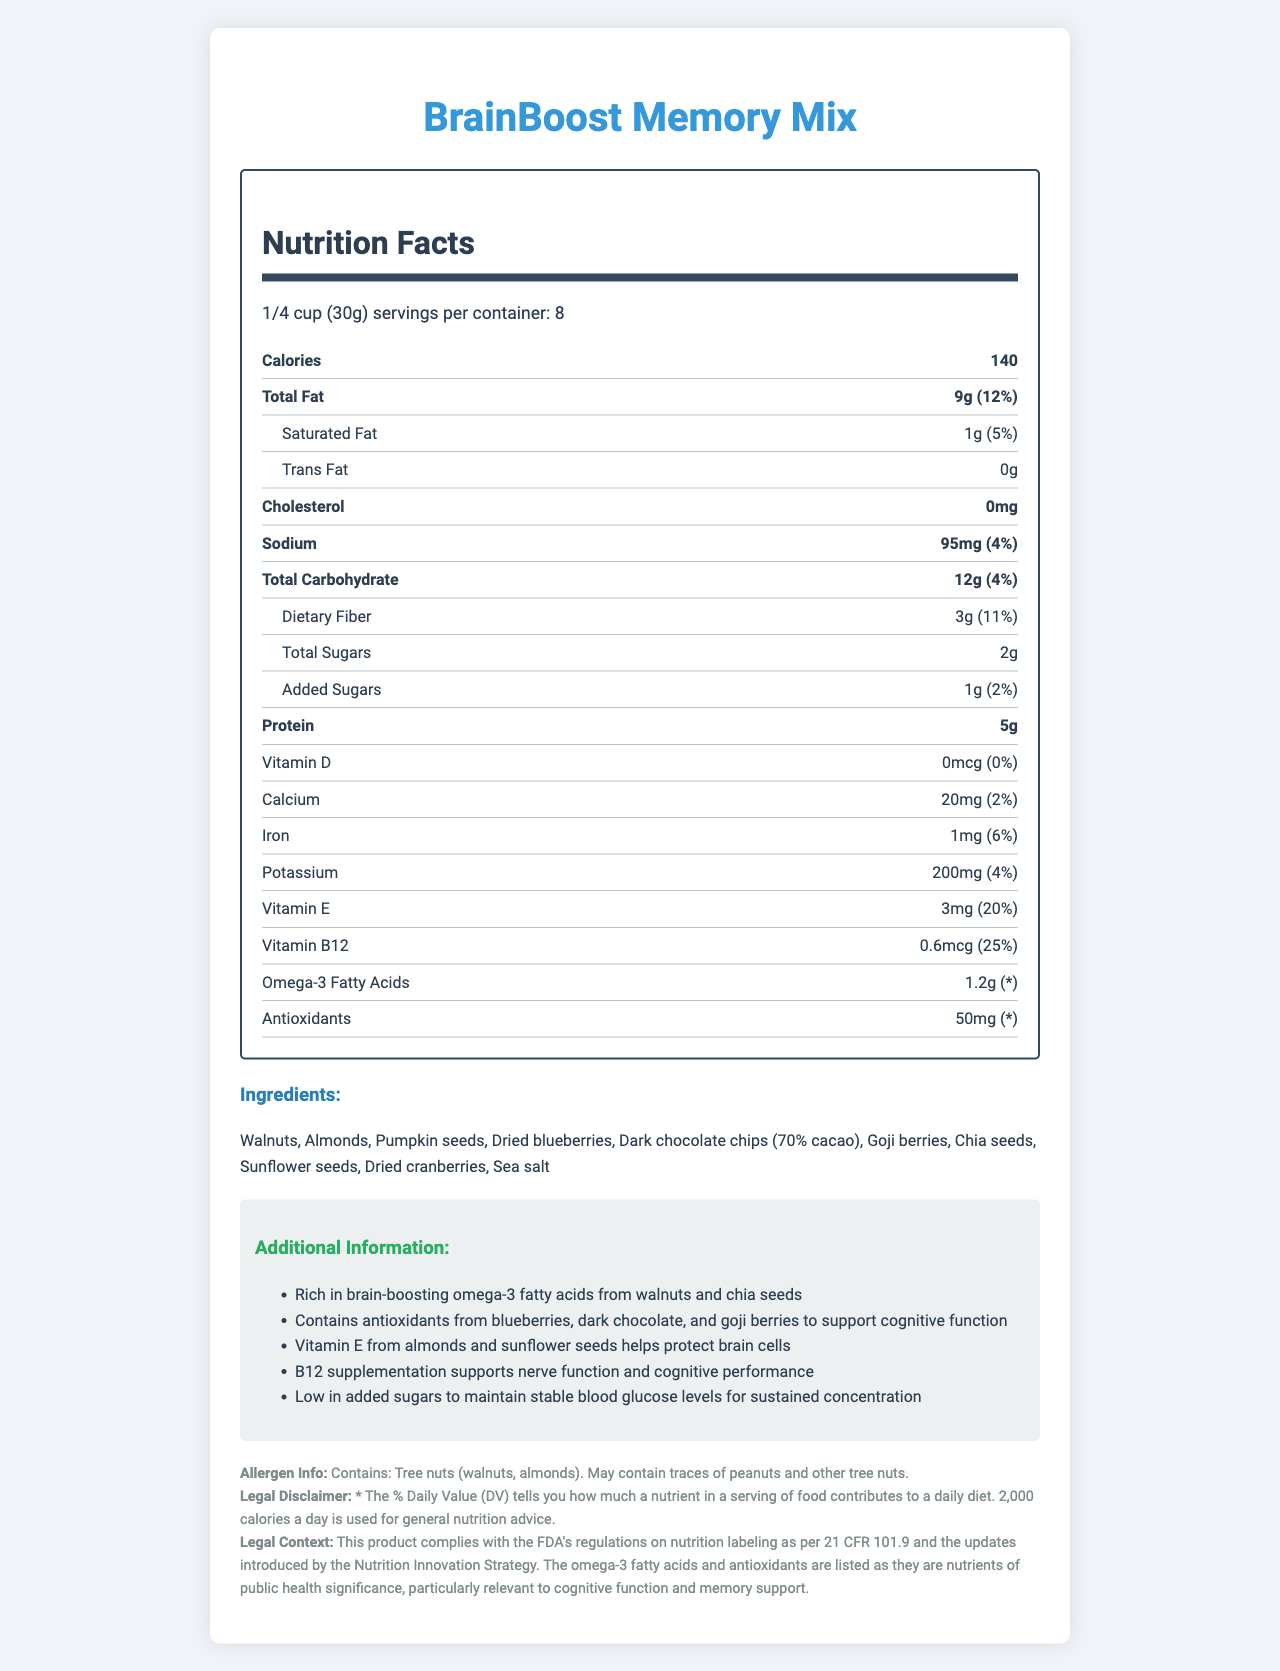How many calories are there per serving? The label states that there are 140 calories per serving.
Answer: 140 What is the serving size of BrainBoost Memory Mix? The document specifies the serving size as 1/4 cup (30g).
Answer: 1/4 cup (30g) How many servings are there in one container? The label indicates that there are 8 servings per container.
Answer: 8 What is the total amount of fat per serving? The document lists the total fat as 9g per serving.
Answer: 9g How much protein does one serving of the snack mix contain? The label specifies that one serving contains 5g of protein.
Answer: 5g Which nutrient has the highest percentage of Daily Value? A. Vitamin B12 B. Vitamin E C. Dietary Fiber D. Iron The document shows that Vitamin B12 has a Daily Value percentage of 25%, which is the highest among the listed nutrients.
Answer: A. Vitamin B12 What is the amount of omega-3 fatty acids per serving? The document specifies that there are 1.2g of omega-3 fatty acids per serving.
Answer: 1.2g Does the snack mix contain any cholesterol? The label indicates that the cholesterol content is 0mg, meaning it contains no cholesterol.
Answer: No Which of the following is NOT an ingredient in the BrainBoost Memory Mix? A. Walnuts B. Dark chocolate chips C. Peanuts D. Dried cranberries Peanuts are not listed in the ingredients; the mix includes walnuts, dark chocolate chips, and dried cranberries, but not peanuts.
Answer: C. Peanuts Is the product compliant with FDA regulations? The legal context section states that the product complies with the FDA's regulations on nutrition labeling as per 21 CFR 101.9.
Answer: Yes Summarize the main purpose and benefits of the BrainBoost Memory Mix. The document is a detailed nutrition label highlighting the cognitive benefits of the snack mix, which includes specific nutrients and vitamins to enhance brain function.
Answer: The BrainBoost Memory Mix is designed to support memory and concentration, featuring ingredients rich in omega-3 fatty acids and antioxidants. It includes walnuts, almonds, pumpkin seeds, dried blueberries, dark chocolate chips, goji berries, chia seeds, sunflower seeds, dried cranberries, and sea salt. The mix also includes Vitamin E and B12 for cognitive support and is low in added sugars. What are the exact amounts of calcium and iron per serving? The label lists 20mg of calcium and 1mg of iron per serving.
Answer: 20mg of calcium and 1mg of iron How does the product help with brain function? The additional information section explains that the product contains omega-3 fatty acids from walnuts and chia seeds, antioxidants from blueberries, dark chocolate, and goji berries, Vitamin E from almonds and sunflower seeds, and B12 to support nerve function and cognitive performance.
Answer: It contains omega-3 fatty acids, antioxidants, Vitamin E, and Vitamin B12, all of which are beneficial for cognitive function and memory support. What is the amount of total sugars per serving? The document specifies that there are 2g of total sugars per serving.
Answer: 2g Is the amount of omega-3 fatty acids listed as a percentage of the Daily Value? The label lists the amount of omega-3 fatty acids as 1.2g but does not provide a percentage of the Daily Value.
Answer: No What specific antioxidant-rich ingredients are included in the snack mix? The additional information section states that antioxidants come from blueberries, dark chocolate, and goji berries.
Answer: Blueberries, dark chocolate, and goji berries How much added sugar is there per serving and what is its Daily Value percentage? The label specifies that there are 1g of added sugars per serving, contributing to 2% of the Daily Value.
Answer: 1g, 2% What is the main ingredient that provides omega-3 fatty acids? The additional information section explains that omega-3 fatty acids come from walnuts and chia seeds.
Answer: Walnuts and chia seeds Explain the allergen information provided on the label. The label clearly states that the product contains tree nuts (walnuts and almonds) and may contain traces of peanuts and other tree nuts, which is important for those with allergies.
Answer: Contains tree nuts (walnuts, almonds) and may contain traces of peanuts and other tree nuts. How many grams of dietary fiber are in one serving? The label lists 3g of dietary fiber per serving.
Answer: 3g What is the benefit of Vitamin E in this snack mix? The additional information section specifies that Vitamin E from almonds and sunflower seeds helps protect brain cells.
Answer: Protects brain cells Which nutrient has the smallest percentage of Daily Value? The label indicates that Vitamin D has 0% of the Daily Value.
Answer: Vitamin D What ingredients are responsible for the low added sugars in the snack mix? The additional information section explains that the product is low in added sugars to maintain stable blood glucose levels for sustained concentration; this implies the ingredients as formulated are naturally lower in sugars with minimal additions.
Answer: The mix itself along with the low quantity of added sugars What might be the potential presence of allergens not explicitly listed in the main ingredient's list? The allergen info section mentions that the product may contain traces of peanuts and other tree nuts.
Answer: Traces of peanuts and other tree nuts Evaluate the legal disclaimer mentioned in the document. The legal disclaimer explains how the Daily Value percentages are calculated and provides a reference point by saying that they use a 2,000-calorie daily diet as a standard for general nutrition advice. This is in line with FDA guidelines.
Answer: "* The % Daily Value (DV) tells you how much a nutrient in a serving of food contributes to a daily diet. 2,000 calories a day is used for general nutrition advice." 